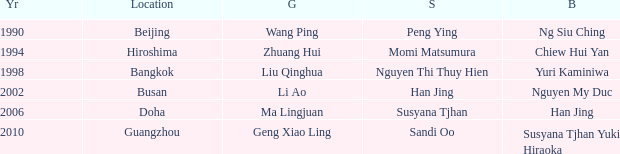Parse the full table. {'header': ['Yr', 'Location', 'G', 'S', 'B'], 'rows': [['1990', 'Beijing', 'Wang Ping', 'Peng Ying', 'Ng Siu Ching'], ['1994', 'Hiroshima', 'Zhuang Hui', 'Momi Matsumura', 'Chiew Hui Yan'], ['1998', 'Bangkok', 'Liu Qinghua', 'Nguyen Thi Thuy Hien', 'Yuri Kaminiwa'], ['2002', 'Busan', 'Li Ao', 'Han Jing', 'Nguyen My Duc'], ['2006', 'Doha', 'Ma Lingjuan', 'Susyana Tjhan', 'Han Jing'], ['2010', 'Guangzhou', 'Geng Xiao Ling', 'Sandi Oo', 'Susyana Tjhan Yuki Hiraoka']]} What Gold has the Year of 1994? Zhuang Hui. 